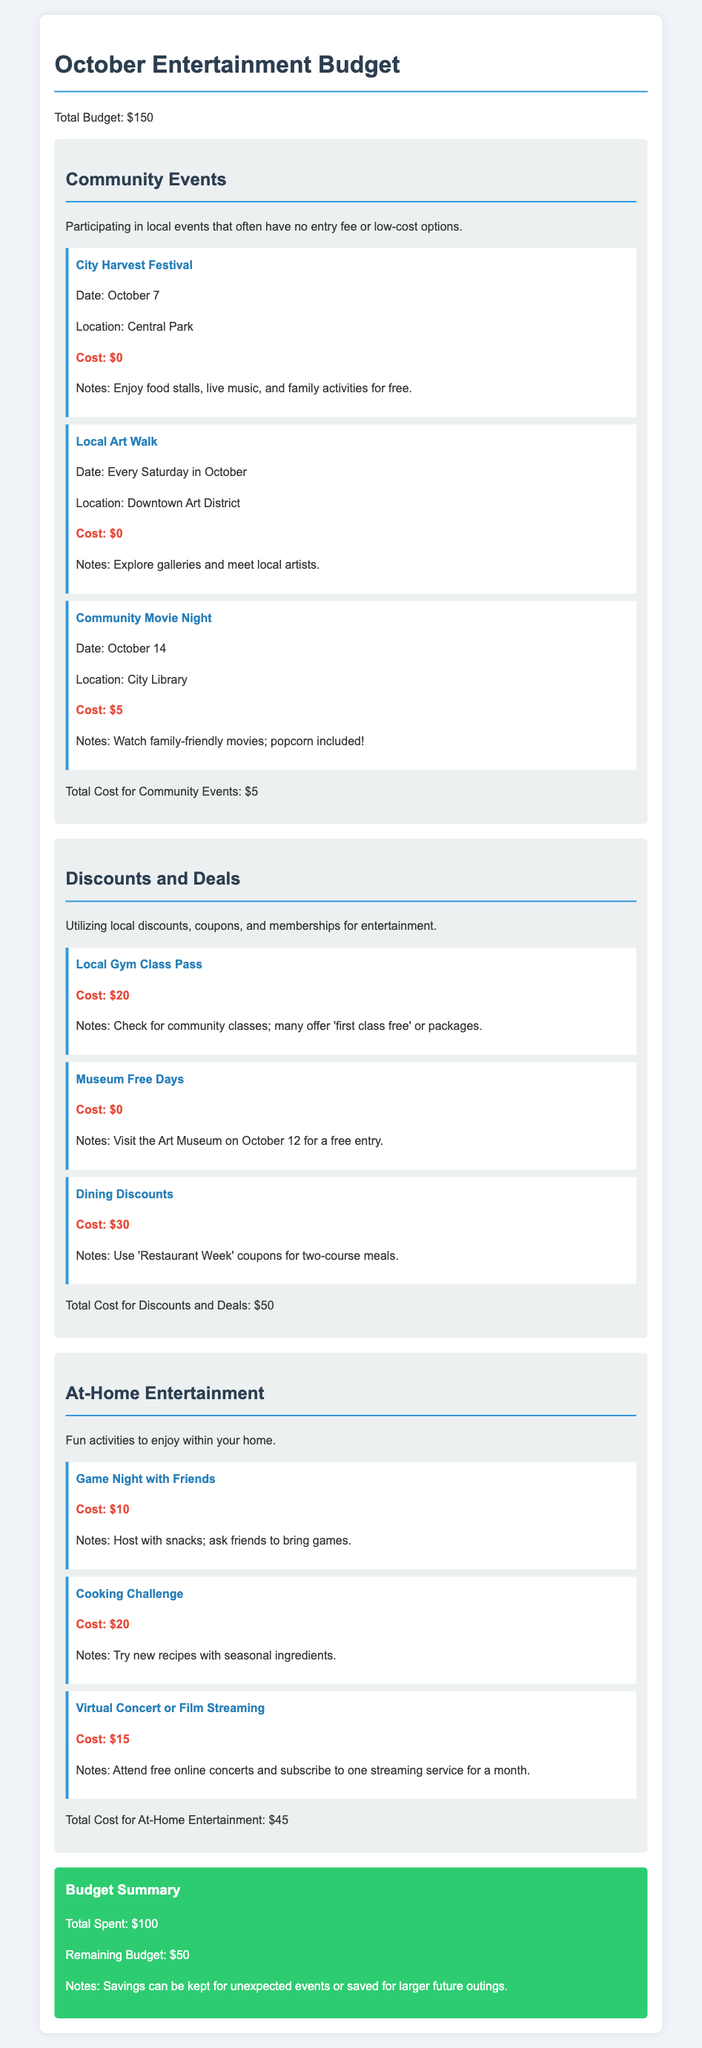What is the total budget for October entertainment? The total budget is stated at the beginning of the document.
Answer: $150 When is the City Harvest Festival taking place? The date for the City Harvest Festival is provided in the event details.
Answer: October 7 What is the cost of attending the Community Movie Night? The document lists the cost for the Community Movie Night specifically.
Answer: $5 How much is spent on discounts and deals? The total cost for discounts and deals is summarized at the end of the section.
Answer: $50 What activity is planned for at-home entertainment that costs $20? The document describes the Cooking Challenge as one of the at-home activities.
Answer: Cooking Challenge What is the remaining budget after all planned spending? The summary section indicates how much money is left after expenses.
Answer: $50 How many community events are listed in the budget? The number of events can be counted from the community events section.
Answer: 3 What is included in the Museum Free Days option? The information about free entry on a specific date is detailed in that section.
Answer: Free entry on October 12 What type of entertainment is mentioned for October 14? The event category specifies what is happening on October 14.
Answer: Community Movie Night 